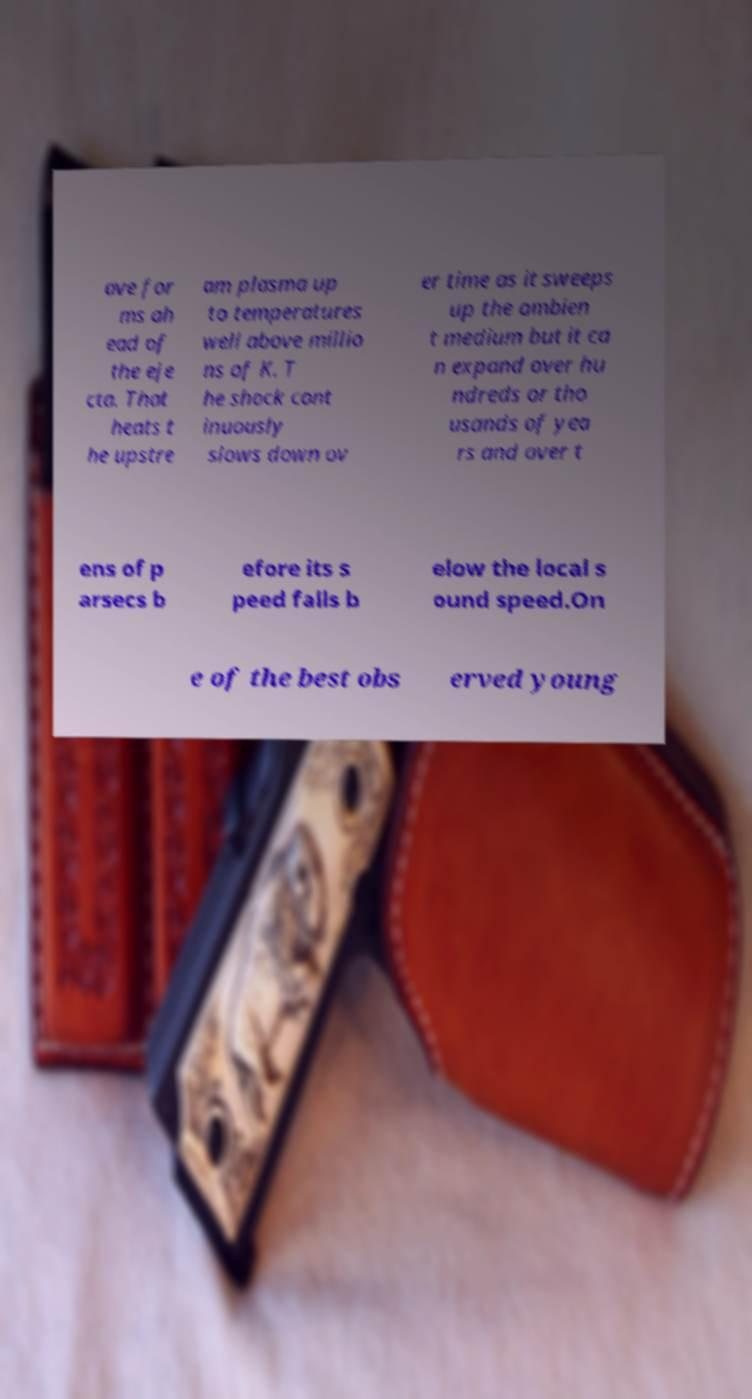I need the written content from this picture converted into text. Can you do that? ave for ms ah ead of the eje cta. That heats t he upstre am plasma up to temperatures well above millio ns of K. T he shock cont inuously slows down ov er time as it sweeps up the ambien t medium but it ca n expand over hu ndreds or tho usands of yea rs and over t ens of p arsecs b efore its s peed falls b elow the local s ound speed.On e of the best obs erved young 